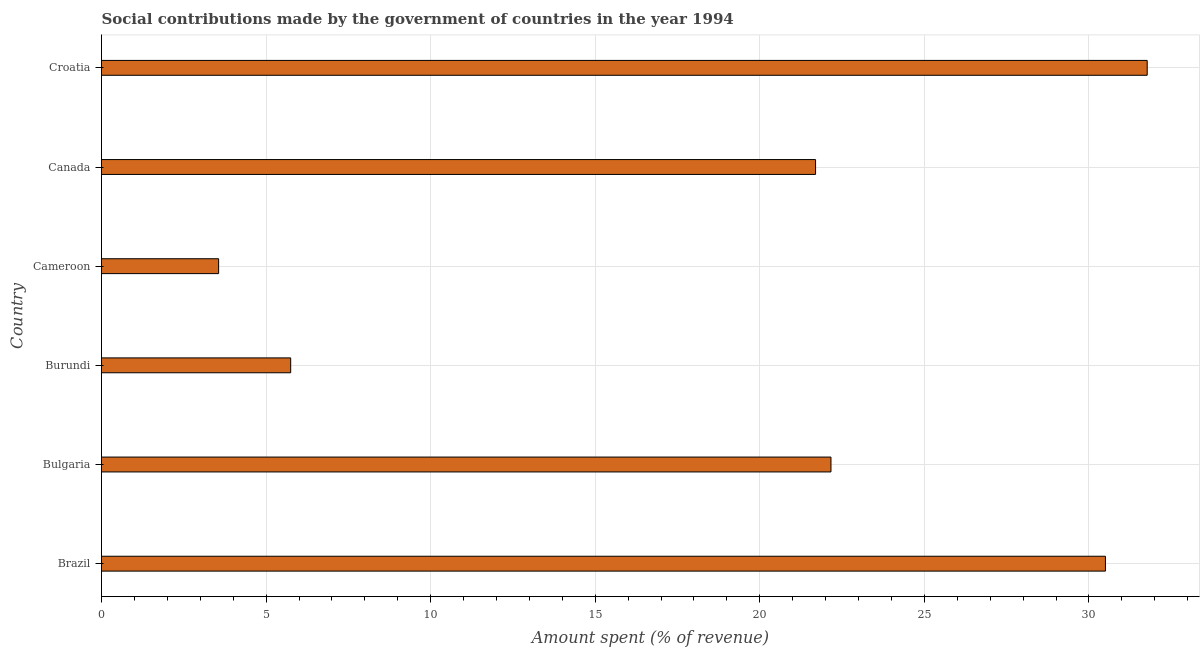Does the graph contain grids?
Provide a short and direct response. Yes. What is the title of the graph?
Offer a terse response. Social contributions made by the government of countries in the year 1994. What is the label or title of the X-axis?
Make the answer very short. Amount spent (% of revenue). What is the amount spent in making social contributions in Brazil?
Ensure brevity in your answer.  30.5. Across all countries, what is the maximum amount spent in making social contributions?
Provide a short and direct response. 31.77. Across all countries, what is the minimum amount spent in making social contributions?
Your answer should be very brief. 3.56. In which country was the amount spent in making social contributions maximum?
Give a very brief answer. Croatia. In which country was the amount spent in making social contributions minimum?
Make the answer very short. Cameroon. What is the sum of the amount spent in making social contributions?
Ensure brevity in your answer.  115.43. What is the difference between the amount spent in making social contributions in Burundi and Canada?
Keep it short and to the point. -15.95. What is the average amount spent in making social contributions per country?
Provide a succinct answer. 19.24. What is the median amount spent in making social contributions?
Your response must be concise. 21.93. What is the ratio of the amount spent in making social contributions in Bulgaria to that in Croatia?
Offer a terse response. 0.7. Is the amount spent in making social contributions in Burundi less than that in Canada?
Offer a very short reply. Yes. Is the difference between the amount spent in making social contributions in Burundi and Cameroon greater than the difference between any two countries?
Offer a very short reply. No. What is the difference between the highest and the second highest amount spent in making social contributions?
Give a very brief answer. 1.27. What is the difference between the highest and the lowest amount spent in making social contributions?
Your answer should be very brief. 28.21. In how many countries, is the amount spent in making social contributions greater than the average amount spent in making social contributions taken over all countries?
Offer a very short reply. 4. Are all the bars in the graph horizontal?
Offer a terse response. Yes. How many countries are there in the graph?
Your response must be concise. 6. What is the difference between two consecutive major ticks on the X-axis?
Your answer should be compact. 5. Are the values on the major ticks of X-axis written in scientific E-notation?
Give a very brief answer. No. What is the Amount spent (% of revenue) in Brazil?
Make the answer very short. 30.5. What is the Amount spent (% of revenue) in Bulgaria?
Ensure brevity in your answer.  22.16. What is the Amount spent (% of revenue) of Burundi?
Keep it short and to the point. 5.75. What is the Amount spent (% of revenue) in Cameroon?
Keep it short and to the point. 3.56. What is the Amount spent (% of revenue) of Canada?
Ensure brevity in your answer.  21.69. What is the Amount spent (% of revenue) of Croatia?
Your answer should be very brief. 31.77. What is the difference between the Amount spent (% of revenue) in Brazil and Bulgaria?
Keep it short and to the point. 8.34. What is the difference between the Amount spent (% of revenue) in Brazil and Burundi?
Your response must be concise. 24.75. What is the difference between the Amount spent (% of revenue) in Brazil and Cameroon?
Provide a short and direct response. 26.94. What is the difference between the Amount spent (% of revenue) in Brazil and Canada?
Keep it short and to the point. 8.81. What is the difference between the Amount spent (% of revenue) in Brazil and Croatia?
Offer a terse response. -1.27. What is the difference between the Amount spent (% of revenue) in Bulgaria and Burundi?
Offer a terse response. 16.41. What is the difference between the Amount spent (% of revenue) in Bulgaria and Cameroon?
Provide a succinct answer. 18.6. What is the difference between the Amount spent (% of revenue) in Bulgaria and Canada?
Provide a succinct answer. 0.47. What is the difference between the Amount spent (% of revenue) in Bulgaria and Croatia?
Your answer should be very brief. -9.61. What is the difference between the Amount spent (% of revenue) in Burundi and Cameroon?
Your response must be concise. 2.19. What is the difference between the Amount spent (% of revenue) in Burundi and Canada?
Give a very brief answer. -15.95. What is the difference between the Amount spent (% of revenue) in Burundi and Croatia?
Your answer should be compact. -26.02. What is the difference between the Amount spent (% of revenue) in Cameroon and Canada?
Ensure brevity in your answer.  -18.14. What is the difference between the Amount spent (% of revenue) in Cameroon and Croatia?
Make the answer very short. -28.21. What is the difference between the Amount spent (% of revenue) in Canada and Croatia?
Make the answer very short. -10.08. What is the ratio of the Amount spent (% of revenue) in Brazil to that in Bulgaria?
Offer a terse response. 1.38. What is the ratio of the Amount spent (% of revenue) in Brazil to that in Burundi?
Make the answer very short. 5.31. What is the ratio of the Amount spent (% of revenue) in Brazil to that in Cameroon?
Provide a succinct answer. 8.57. What is the ratio of the Amount spent (% of revenue) in Brazil to that in Canada?
Give a very brief answer. 1.41. What is the ratio of the Amount spent (% of revenue) in Brazil to that in Croatia?
Offer a very short reply. 0.96. What is the ratio of the Amount spent (% of revenue) in Bulgaria to that in Burundi?
Offer a very short reply. 3.86. What is the ratio of the Amount spent (% of revenue) in Bulgaria to that in Cameroon?
Provide a succinct answer. 6.23. What is the ratio of the Amount spent (% of revenue) in Bulgaria to that in Croatia?
Make the answer very short. 0.7. What is the ratio of the Amount spent (% of revenue) in Burundi to that in Cameroon?
Provide a short and direct response. 1.61. What is the ratio of the Amount spent (% of revenue) in Burundi to that in Canada?
Provide a succinct answer. 0.27. What is the ratio of the Amount spent (% of revenue) in Burundi to that in Croatia?
Your response must be concise. 0.18. What is the ratio of the Amount spent (% of revenue) in Cameroon to that in Canada?
Offer a very short reply. 0.16. What is the ratio of the Amount spent (% of revenue) in Cameroon to that in Croatia?
Provide a succinct answer. 0.11. What is the ratio of the Amount spent (% of revenue) in Canada to that in Croatia?
Offer a very short reply. 0.68. 